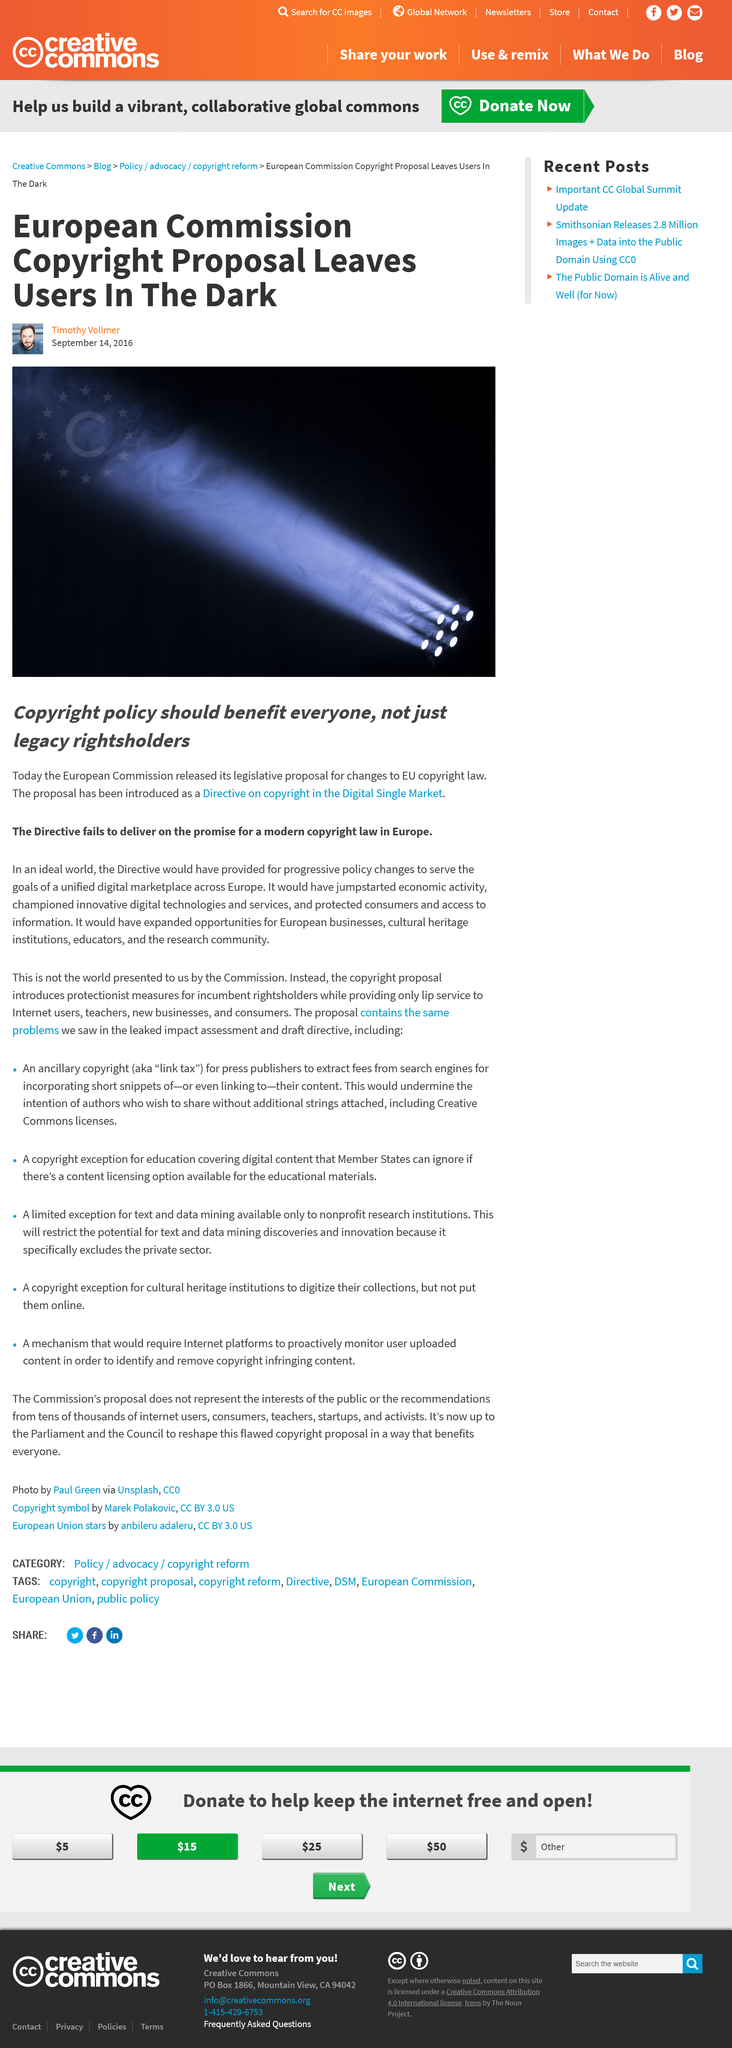Outline some significant characteristics in this image. The name of the man in the small portrait under the title is Timothy Vollmer. The author believes that the directive does not fulfill the promise for a modern copyright law in Europe. The European Commission released its legislative proposal for changes to EU copyright law. 